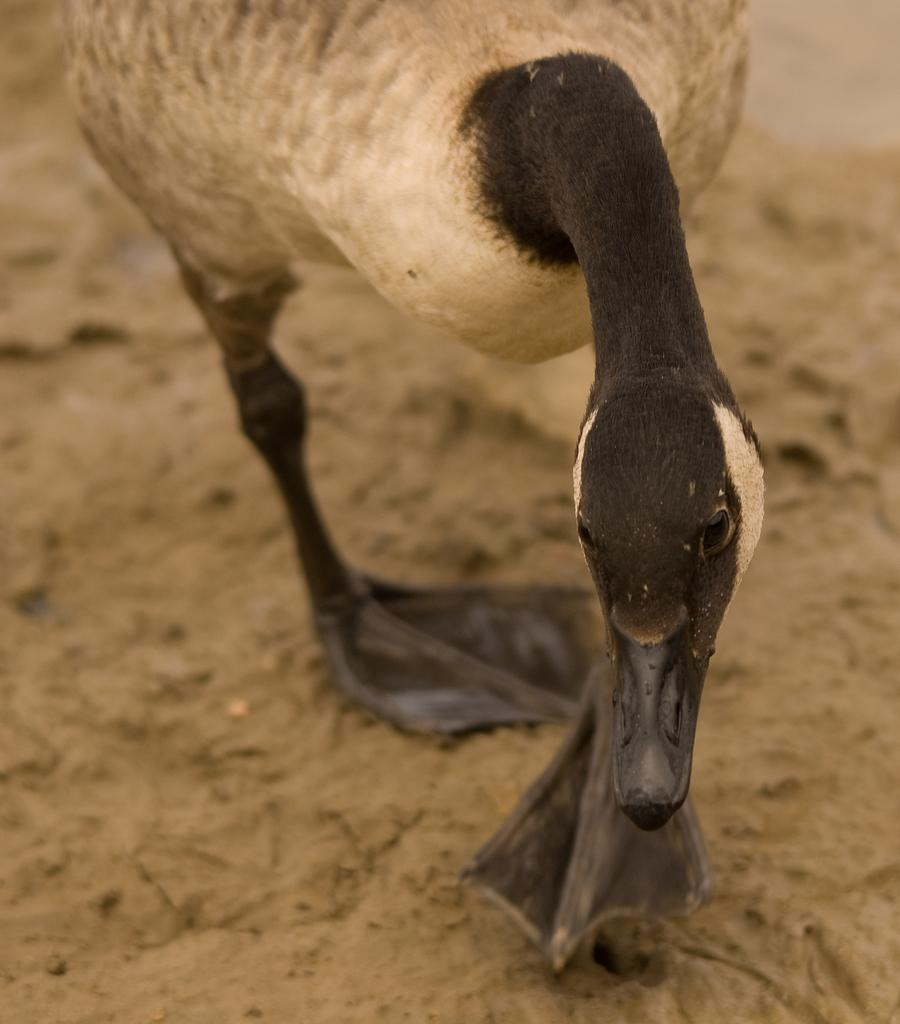What type of animal is in the image? There is a bird in the image. Can you describe the bird's coloring? The bird is in black and cream color. What type of insurance does the bird's manager recommend in the image? There is no mention of insurance, a manager, or any recommendation in the image; it only features a bird in black and cream color. 